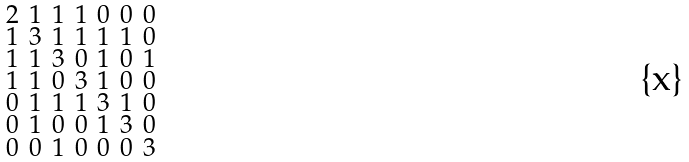<formula> <loc_0><loc_0><loc_500><loc_500>\begin{smallmatrix} 2 & 1 & 1 & 1 & 0 & 0 & 0 \\ 1 & 3 & 1 & 1 & 1 & 1 & 0 \\ 1 & 1 & 3 & 0 & 1 & 0 & 1 \\ 1 & 1 & 0 & 3 & 1 & 0 & 0 \\ 0 & 1 & 1 & 1 & 3 & 1 & 0 \\ 0 & 1 & 0 & 0 & 1 & 3 & 0 \\ 0 & 0 & 1 & 0 & 0 & 0 & 3 \end{smallmatrix}</formula> 